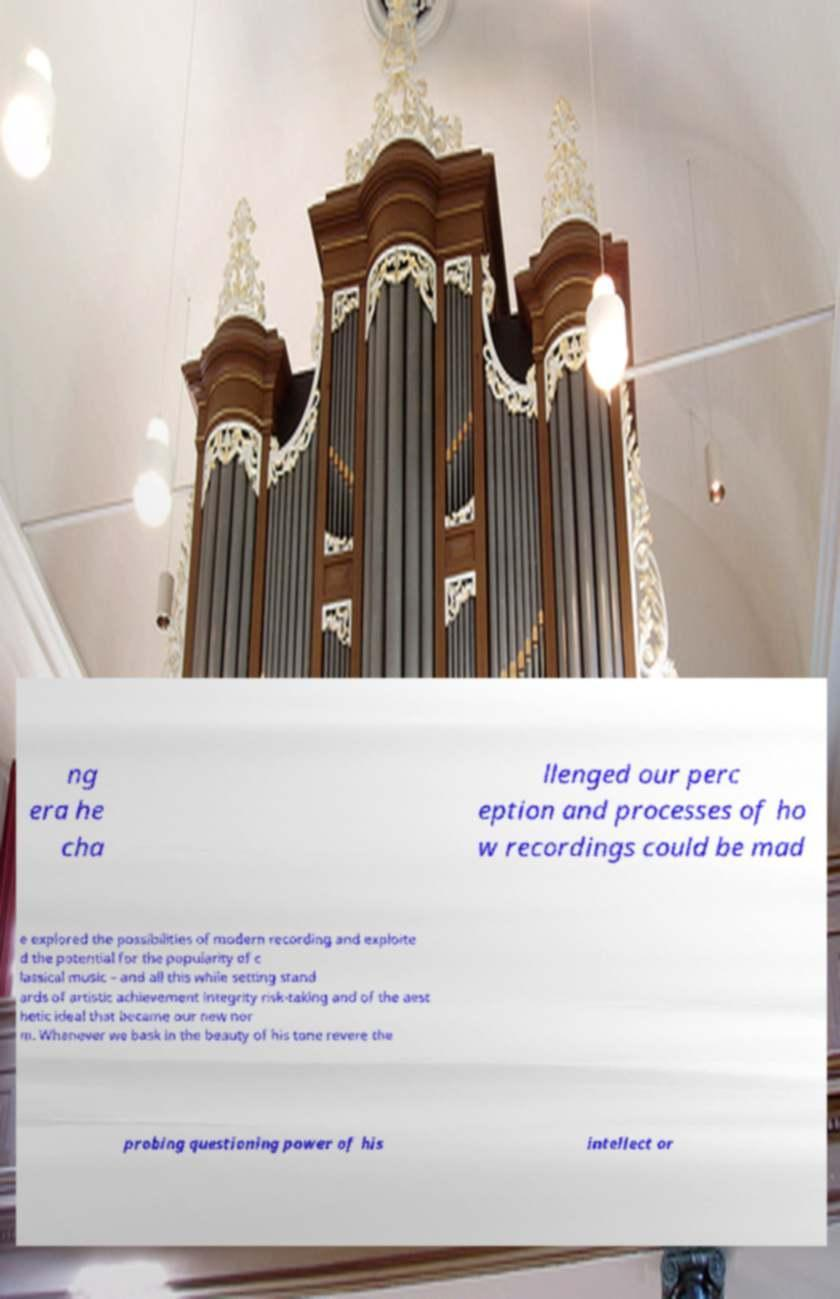There's text embedded in this image that I need extracted. Can you transcribe it verbatim? ng era he cha llenged our perc eption and processes of ho w recordings could be mad e explored the possibilities of modern recording and exploite d the potential for the popularity of c lassical music – and all this while setting stand ards of artistic achievement integrity risk-taking and of the aest hetic ideal that became our new nor m. Whenever we bask in the beauty of his tone revere the probing questioning power of his intellect or 